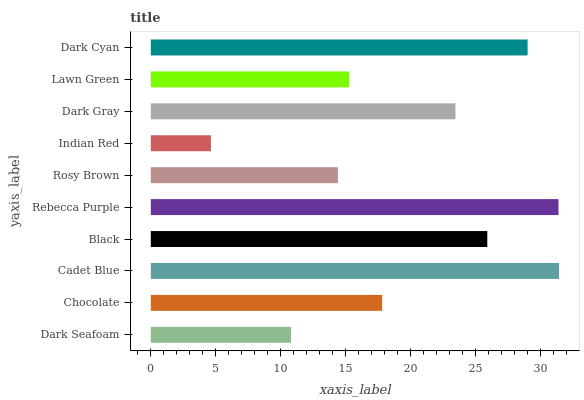Is Indian Red the minimum?
Answer yes or no. Yes. Is Cadet Blue the maximum?
Answer yes or no. Yes. Is Chocolate the minimum?
Answer yes or no. No. Is Chocolate the maximum?
Answer yes or no. No. Is Chocolate greater than Dark Seafoam?
Answer yes or no. Yes. Is Dark Seafoam less than Chocolate?
Answer yes or no. Yes. Is Dark Seafoam greater than Chocolate?
Answer yes or no. No. Is Chocolate less than Dark Seafoam?
Answer yes or no. No. Is Dark Gray the high median?
Answer yes or no. Yes. Is Chocolate the low median?
Answer yes or no. Yes. Is Black the high median?
Answer yes or no. No. Is Lawn Green the low median?
Answer yes or no. No. 